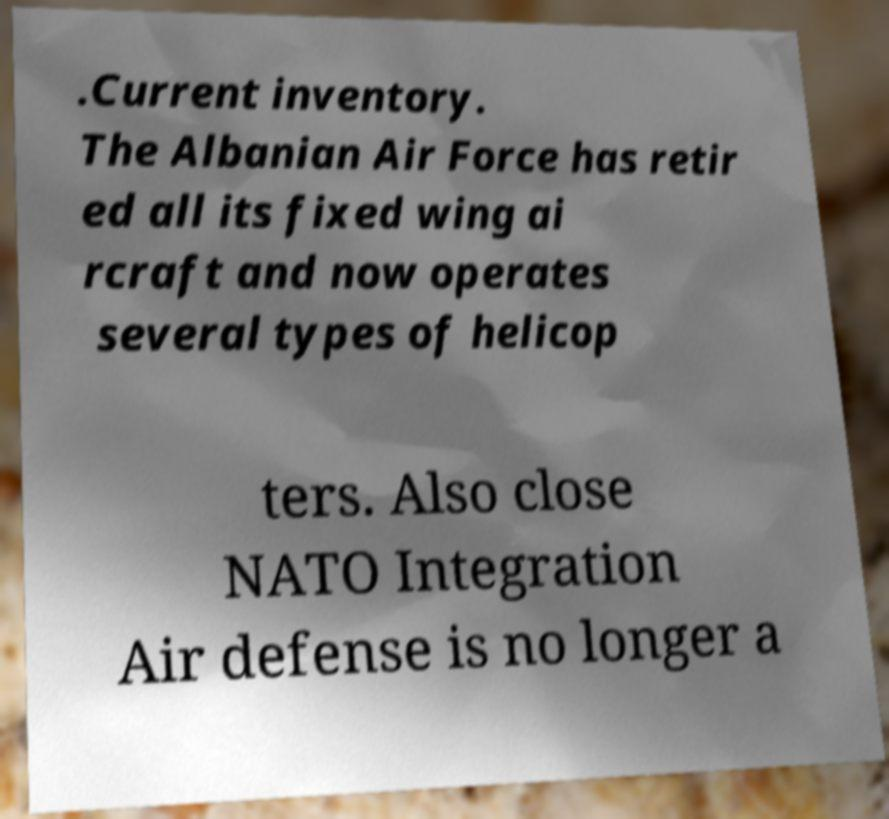There's text embedded in this image that I need extracted. Can you transcribe it verbatim? .Current inventory. The Albanian Air Force has retir ed all its fixed wing ai rcraft and now operates several types of helicop ters. Also close NATO Integration Air defense is no longer a 